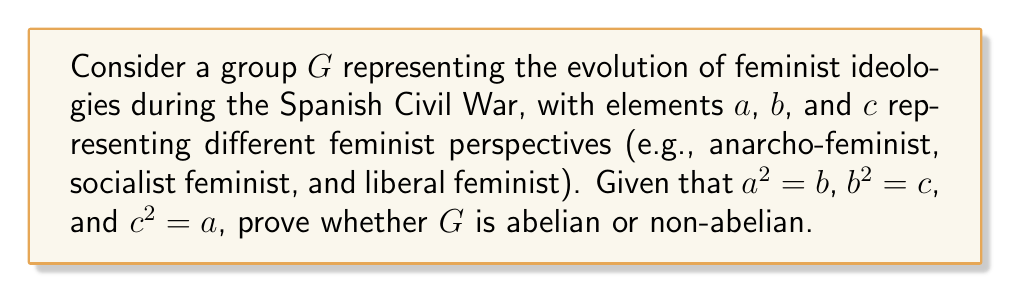Provide a solution to this math problem. To determine whether the group $G$ is abelian or non-abelian, we need to check if all elements in the group commute with each other. In other words, we need to verify if $xy = yx$ for all $x, y \in G$.

Let's examine the products of different elements:

1) First, let's calculate $ab$ and $ba$:
   $ab = a(a^2) = a^3 = (a^2)a = ba$

2) Now, let's calculate $ac$ and $ca$:
   $ac = a(b^2) = (ab)b = (ba)b = b(ab) = b(a^3) = ba^3 = ca$

3) Finally, let's calculate $bc$ and $cb$:
   $bc = (a^2)(b^2) = a^2b^2 = ab^3 = a(bc) = (ab)c = (ba)c = b(ac) = b(ca) = cb$

We can see that for all pairs of elements $x$ and $y$ in $G$, $xy = yx$. This means that all elements in $G$ commute with each other.

The definition of an abelian group is a group in which the operation is commutative, i.e., $xy = yx$ for all $x, y$ in the group. Since we have shown that this property holds for all elements in $G$, we can conclude that $G$ is an abelian group.

This result could be interpreted in the context of the Spanish Civil War as representing the idea that different feminist perspectives, despite their distinctions, could work together and influence each other in a commutative manner during this tumultuous period.
Answer: The group $G$ representing the evolution of feminist ideologies during the Spanish Civil War is abelian. 